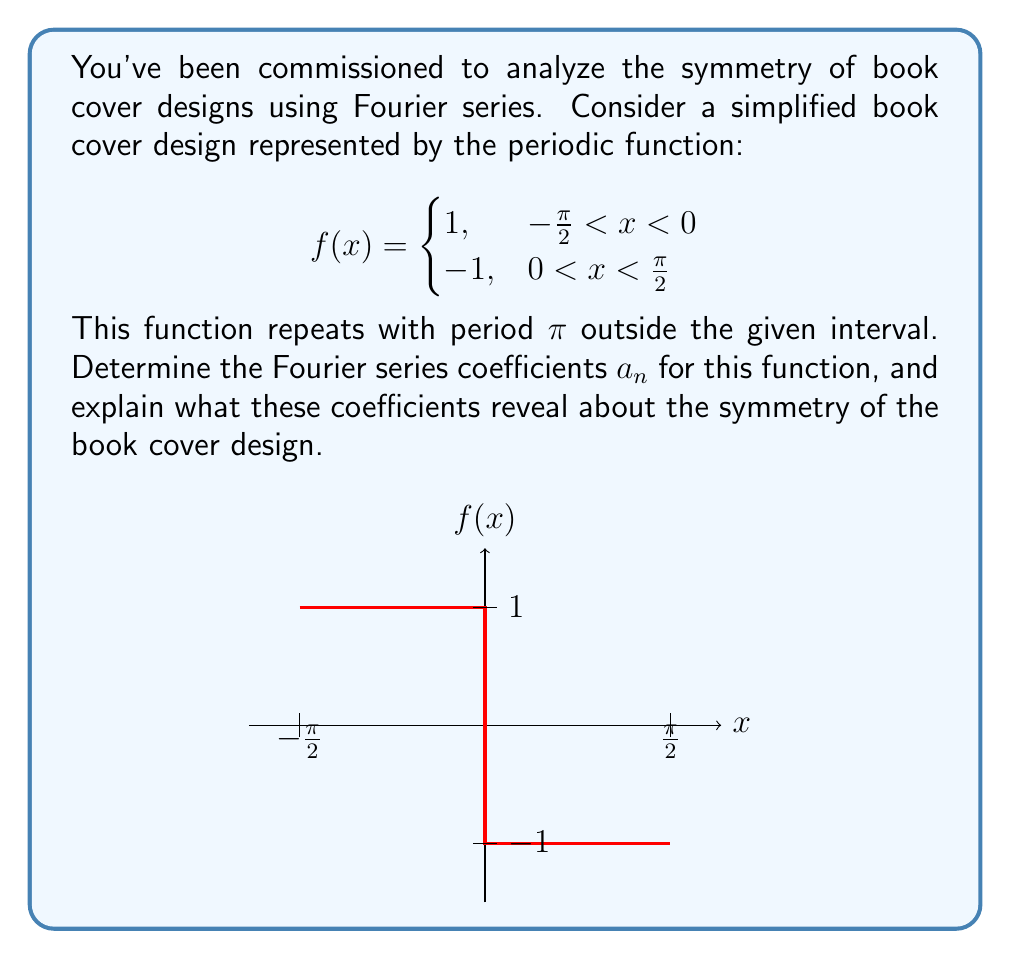Solve this math problem. Let's approach this step-by-step:

1) For a function with period $2\pi$, the Fourier series is given by:

   $$f(x) = \frac{a_0}{2} + \sum_{n=1}^{\infty} (a_n \cos(nx) + b_n \sin(nx))$$

2) Our function has period $\pi$, so we need to adjust our formulas:

   $$a_n = \frac{2}{\pi} \int_{-\pi/2}^{\pi/2} f(x) \cos(2nx) dx$$
   $$b_n = \frac{2}{\pi} \int_{-\pi/2}^{\pi/2} f(x) \sin(2nx) dx$$

3) Due to the odd symmetry of $f(x)$ about $x=0$, all $a_n$ coefficients (including $a_0$) will be zero.

4) For $b_n$:

   $$b_n = \frac{2}{\pi} \left[\int_{-\pi/2}^{0} \cos(2nx) dx - \int_{0}^{\pi/2} \cos(2nx) dx\right]$$

5) Evaluating this integral:

   $$b_n = \frac{2}{\pi} \left[\frac{\sin(2nx)}{2n}\right]_{-\pi/2}^{0} - \frac{2}{\pi} \left[\frac{\sin(2nx)}{2n}\right]_{0}^{\pi/2}$$
   $$b_n = \frac{2}{\pi} \left[0 - \frac{\sin(-n\pi)}{2n} - \frac{\sin(n\pi)}{2n} + 0\right]$$

6) Simplify using $\sin(-n\pi) = -\sin(n\pi)$:

   $$b_n = \frac{2}{\pi} \left[\frac{\sin(n\pi)}{n} - \frac{\sin(n\pi)}{2n}\right] = \frac{4}{\pi n} \sin(n\pi)$$

7) Note that $\sin(n\pi) = 0$ for even $n$, and $(-1)^{(n-1)/2}$ for odd $n$.

Therefore, the non-zero coefficients are:

$$b_n = \begin{cases}
\frac{4}{\pi n} (-1)^{(n-1)/2}, & \text{for odd } n \\
0, & \text{for even } n
\end{cases}$$

These coefficients reveal that the book cover design has odd symmetry (it's an odd function), as all cosine terms ($a_n$) are zero. The alternating signs of the non-zero $b_n$ coefficients for odd $n$ reflect the square wave nature of the design.
Answer: $b_n = \frac{4}{\pi n} (-1)^{(n-1)/2}$ for odd $n$, 0 for even $n$; $a_n = 0$ for all $n$ 